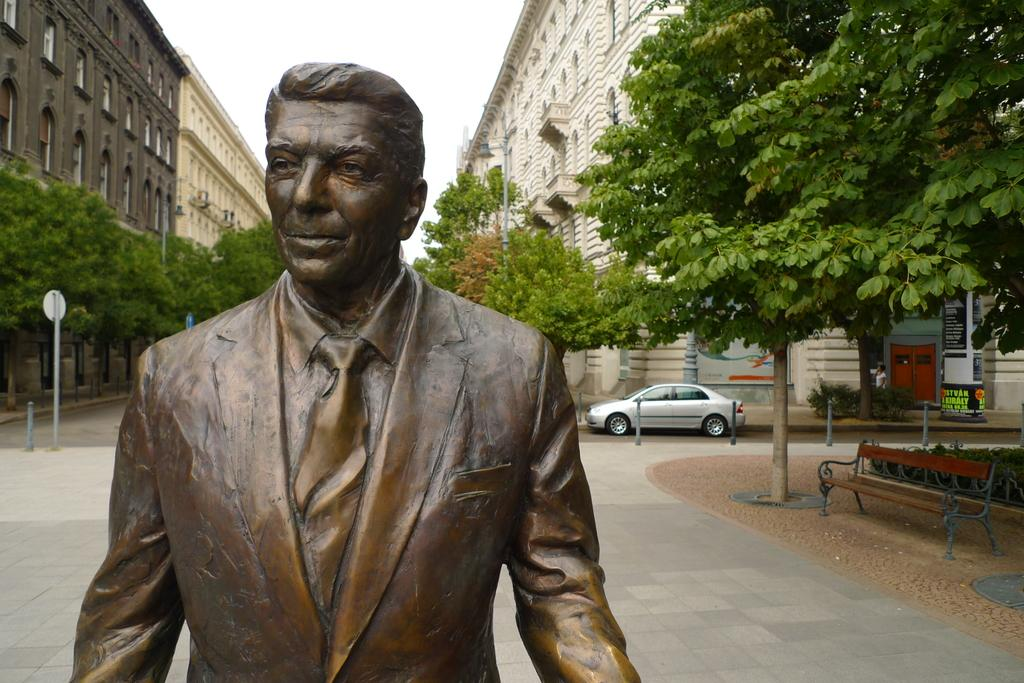What is the main subject in the image? There is a statue present in the image. What else can be seen in the background of the image? There are buildings and trees visible in the image. Is there any transportation visible in the image? Yes, a vehicle is on the road in the image. Are there any seating options in the image? Yes, there is a bench in the image. What type of cork can be seen on the statue in the image? There is no cork present on the statue in the image. What is the zinc content of the trees in the image? The zinc content of the trees cannot be determined from the image. 